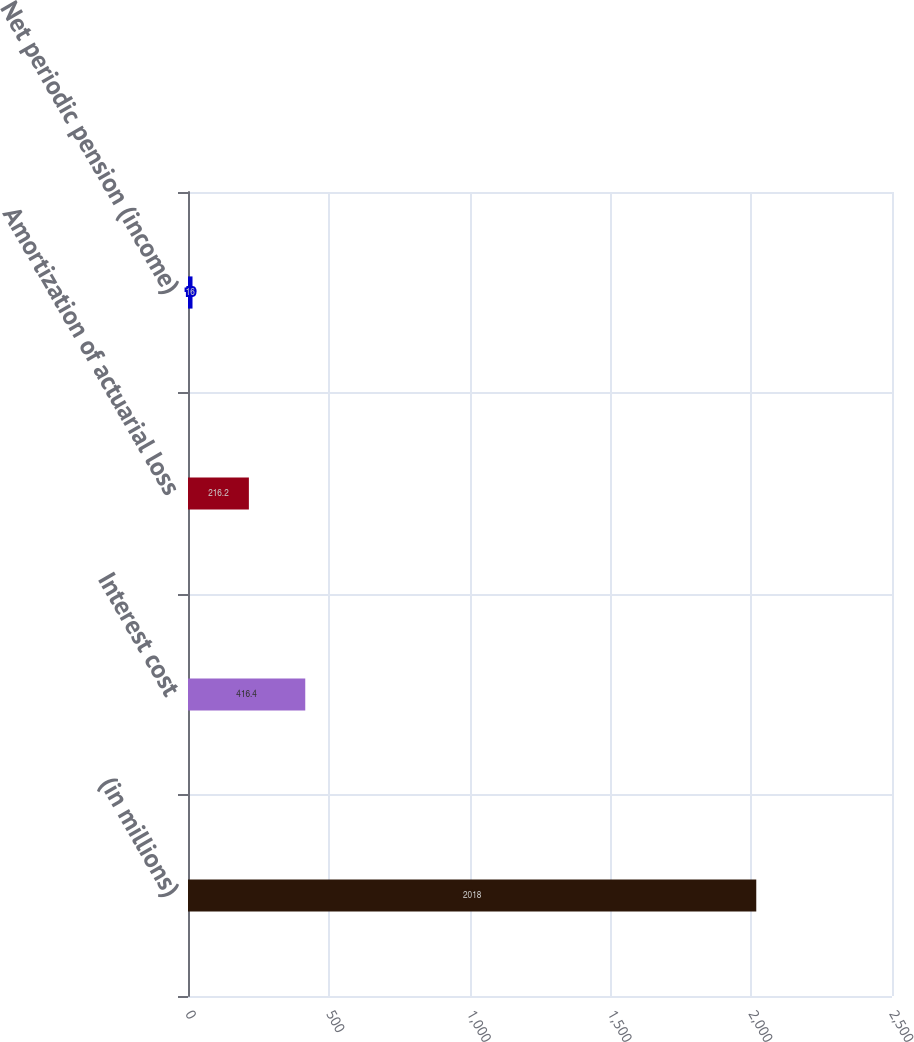Convert chart to OTSL. <chart><loc_0><loc_0><loc_500><loc_500><bar_chart><fcel>(in millions)<fcel>Interest cost<fcel>Amortization of actuarial loss<fcel>Net periodic pension (income)<nl><fcel>2018<fcel>416.4<fcel>216.2<fcel>16<nl></chart> 